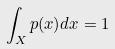Convert formula to latex. <formula><loc_0><loc_0><loc_500><loc_500>\int _ { X } p ( x ) d x = 1</formula> 